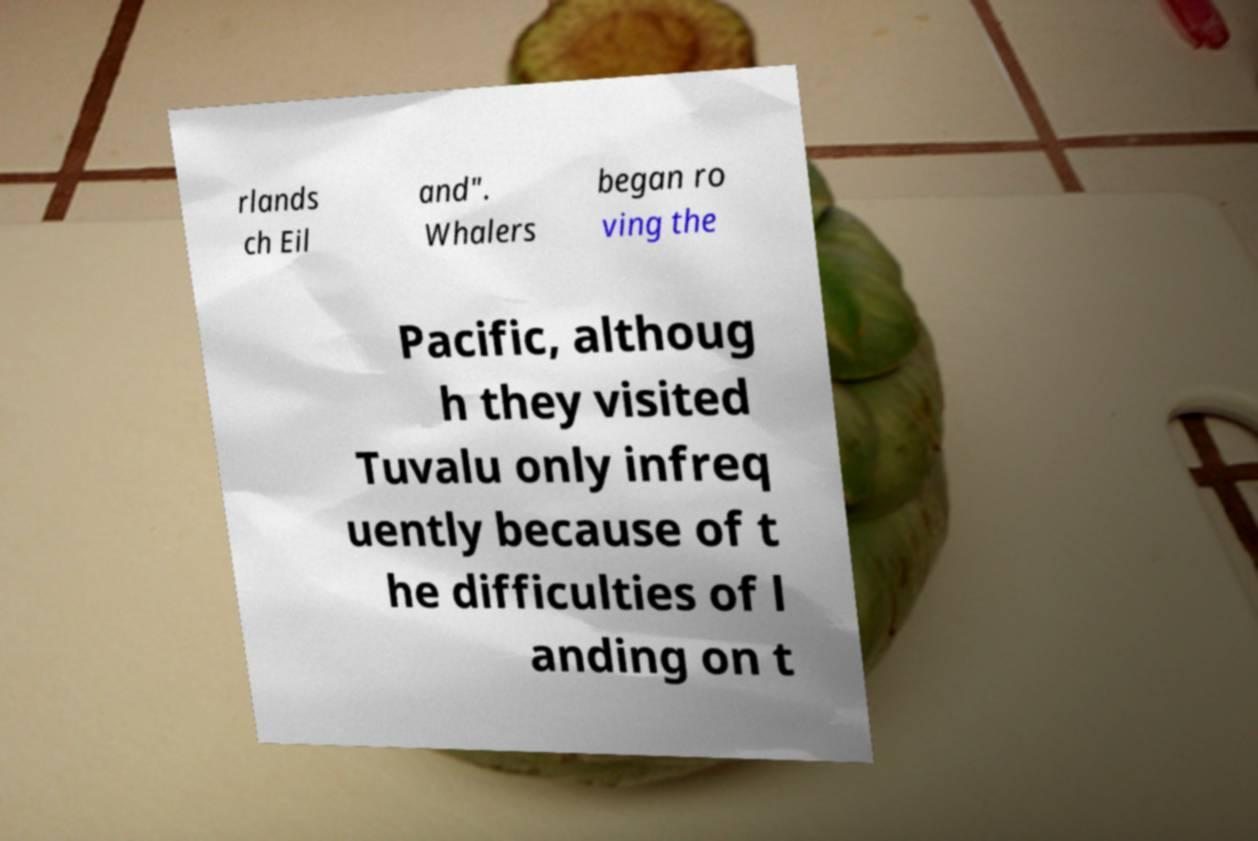Could you assist in decoding the text presented in this image and type it out clearly? rlands ch Eil and". Whalers began ro ving the Pacific, althoug h they visited Tuvalu only infreq uently because of t he difficulties of l anding on t 